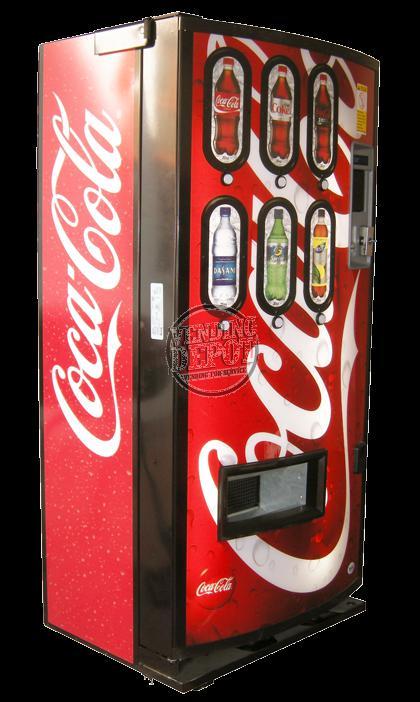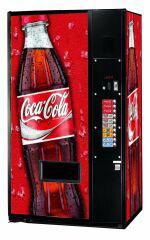The first image is the image on the left, the second image is the image on the right. Considering the images on both sides, is "In one of the images, there are three machines." valid? Answer yes or no. No. 